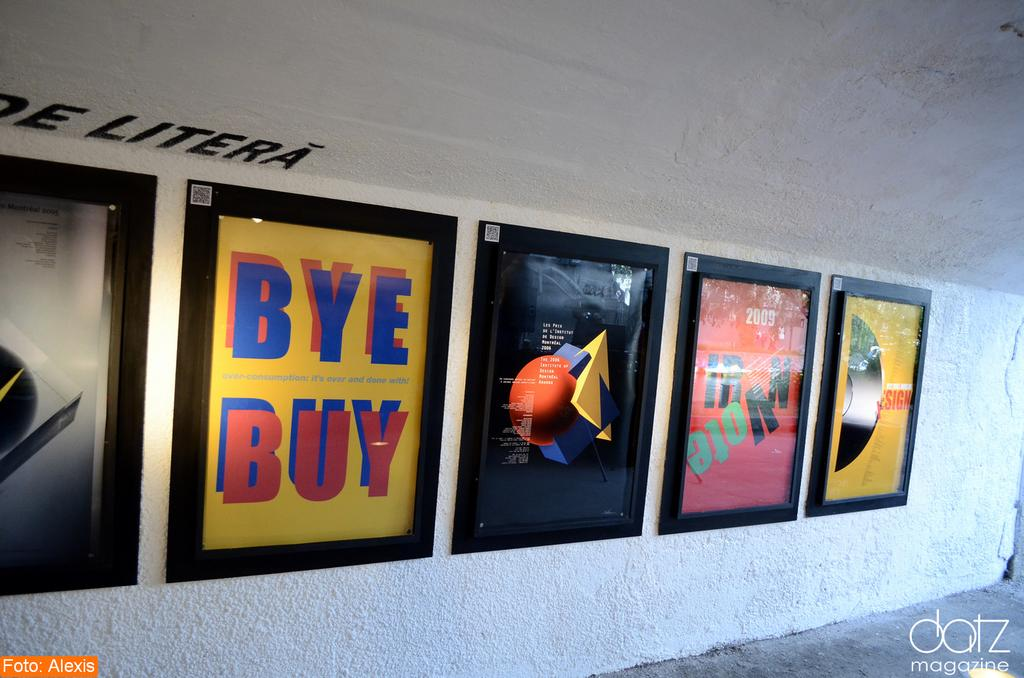<image>
Share a concise interpretation of the image provided. A series of signs, one on fighting overconsumption of goods. 